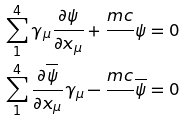Convert formula to latex. <formula><loc_0><loc_0><loc_500><loc_500>\sum _ { 1 } ^ { 4 } \gamma _ { \mu } \frac { \partial \psi } { \partial x _ { \mu } } + \frac { m c } { } \psi & = 0 \\ \sum _ { 1 } ^ { 4 } \frac { \partial \overline { \psi } } { \partial x _ { \mu } } \gamma _ { \mu } - \frac { m c } { } \overline { \psi } & = 0</formula> 